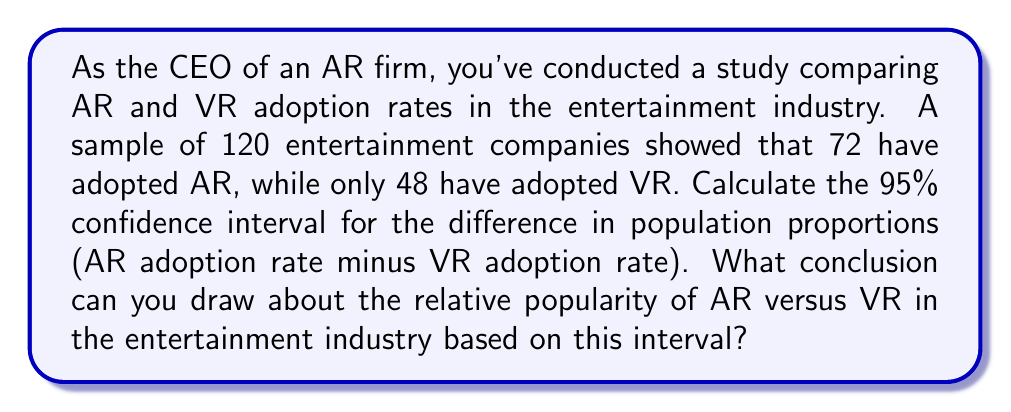Can you solve this math problem? Let's approach this step-by-step:

1) Define our parameters:
   $p_1$ = proportion of companies adopting AR
   $p_2$ = proportion of companies adopting VR
   $n$ = 120 (sample size for both)

2) Calculate sample proportions:
   $\hat{p}_1 = 72/120 = 0.6$
   $\hat{p}_2 = 48/120 = 0.4$

3) The formula for the confidence interval of the difference in proportions is:

   $$(\hat{p}_1 - \hat{p}_2) \pm z_{\alpha/2} \sqrt{\frac{\hat{p}_1(1-\hat{p}_1)}{n_1} + \frac{\hat{p}_2(1-\hat{p}_2)}{n_2}}$$

   Where $z_{\alpha/2}$ is the critical value for a 95% confidence interval, which is 1.96.

4) Calculate the standard error:

   $$SE = \sqrt{\frac{0.6(1-0.6)}{120} + \frac{0.4(1-0.4)}{120}} = \sqrt{\frac{0.24}{120} + \frac{0.24}{120}} = \sqrt{\frac{0.48}{120}} = 0.0632$$

5) Now we can calculate the confidence interval:

   $$(0.6 - 0.4) \pm 1.96(0.0632)$$
   $$0.2 \pm 0.1239$$

6) This gives us the interval:
   (0.0761, 0.3239)

Since this interval is entirely positive, we can conclude with 95% confidence that the true difference in population proportions (AR adoption rate minus VR adoption rate) is between 7.61% and 32.39% in favor of AR.
Answer: (0.0761, 0.3239); AR is more popular than VR in the entertainment industry. 